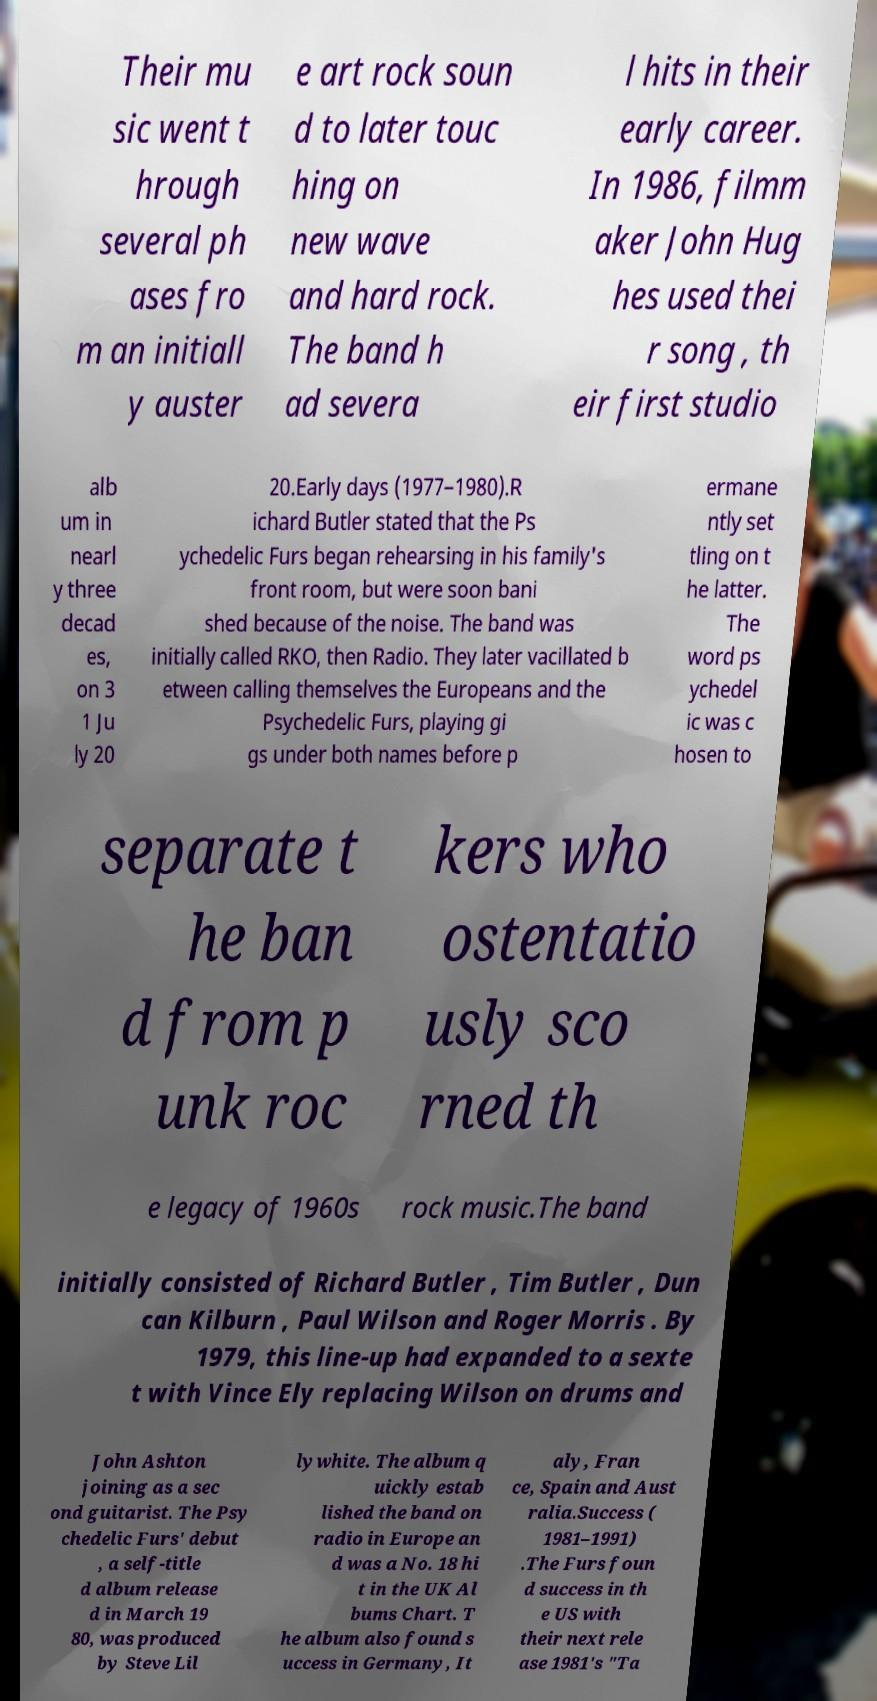For documentation purposes, I need the text within this image transcribed. Could you provide that? Their mu sic went t hrough several ph ases fro m an initiall y auster e art rock soun d to later touc hing on new wave and hard rock. The band h ad severa l hits in their early career. In 1986, filmm aker John Hug hes used thei r song , th eir first studio alb um in nearl y three decad es, on 3 1 Ju ly 20 20.Early days (1977–1980).R ichard Butler stated that the Ps ychedelic Furs began rehearsing in his family's front room, but were soon bani shed because of the noise. The band was initially called RKO, then Radio. They later vacillated b etween calling themselves the Europeans and the Psychedelic Furs, playing gi gs under both names before p ermane ntly set tling on t he latter. The word ps ychedel ic was c hosen to separate t he ban d from p unk roc kers who ostentatio usly sco rned th e legacy of 1960s rock music.The band initially consisted of Richard Butler , Tim Butler , Dun can Kilburn , Paul Wilson and Roger Morris . By 1979, this line-up had expanded to a sexte t with Vince Ely replacing Wilson on drums and John Ashton joining as a sec ond guitarist. The Psy chedelic Furs' debut , a self-title d album release d in March 19 80, was produced by Steve Lil lywhite. The album q uickly estab lished the band on radio in Europe an d was a No. 18 hi t in the UK Al bums Chart. T he album also found s uccess in Germany, It aly, Fran ce, Spain and Aust ralia.Success ( 1981–1991) .The Furs foun d success in th e US with their next rele ase 1981's "Ta 